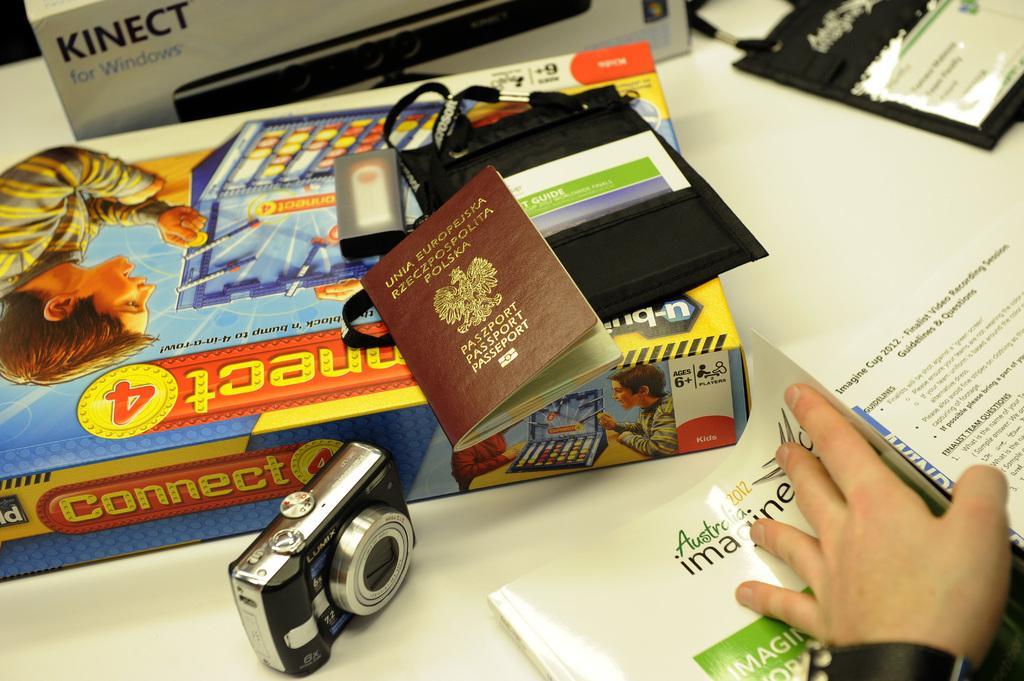Please provide a concise description of this image. In this image I can see the white colored table and on the table I can see a box, few books, a camera which is black and silver in color and to the right bottom of the image I can see a person's hand holding a book and on the box I can see a passport, a black colored bag with few objects in it and I can see few other objects on the table. 